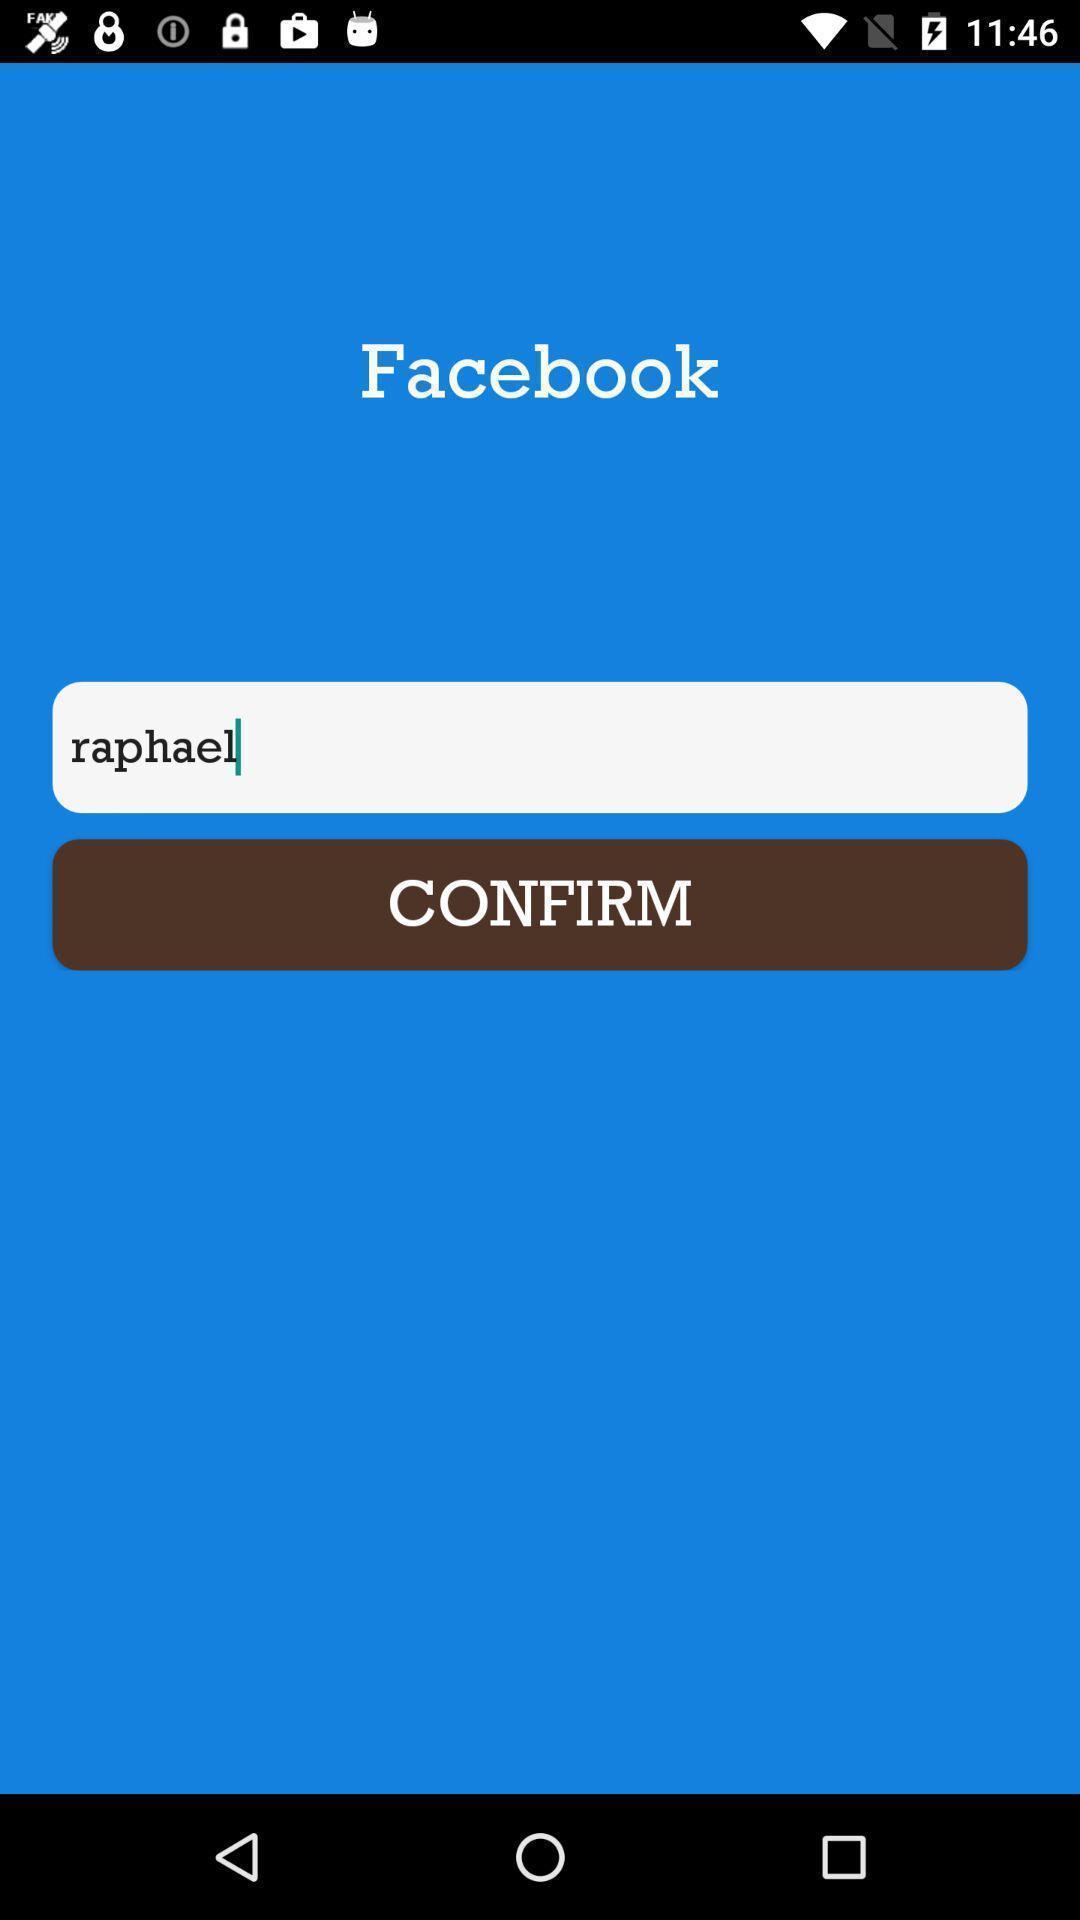Give me a summary of this screen capture. Welcome page of a social application. 